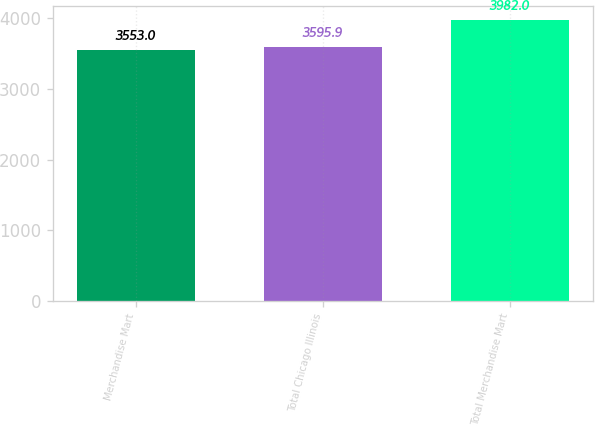Convert chart. <chart><loc_0><loc_0><loc_500><loc_500><bar_chart><fcel>Merchandise Mart<fcel>Total Chicago Illinois<fcel>Total Merchandise Mart<nl><fcel>3553<fcel>3595.9<fcel>3982<nl></chart> 